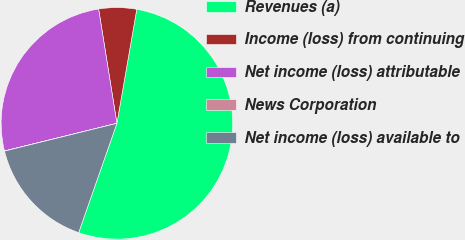Convert chart. <chart><loc_0><loc_0><loc_500><loc_500><pie_chart><fcel>Revenues (a)<fcel>Income (loss) from continuing<fcel>Net income (loss) attributable<fcel>News Corporation<fcel>Net income (loss) available to<nl><fcel>52.61%<fcel>5.27%<fcel>26.31%<fcel>0.02%<fcel>15.79%<nl></chart> 